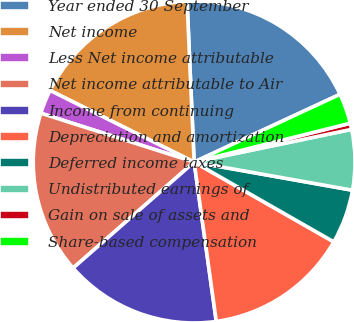Convert chart to OTSL. <chart><loc_0><loc_0><loc_500><loc_500><pie_chart><fcel>Year ended 30 September<fcel>Net income<fcel>Less Net income attributable<fcel>Net income attributable to Air<fcel>Income from continuing<fcel>Depreciation and amortization<fcel>Deferred income taxes<fcel>Undistributed earnings of<fcel>Gain on sale of assets and<fcel>Share-based compensation<nl><fcel>18.78%<fcel>16.96%<fcel>2.43%<fcel>16.36%<fcel>15.75%<fcel>14.54%<fcel>5.46%<fcel>6.06%<fcel>0.62%<fcel>3.04%<nl></chart> 